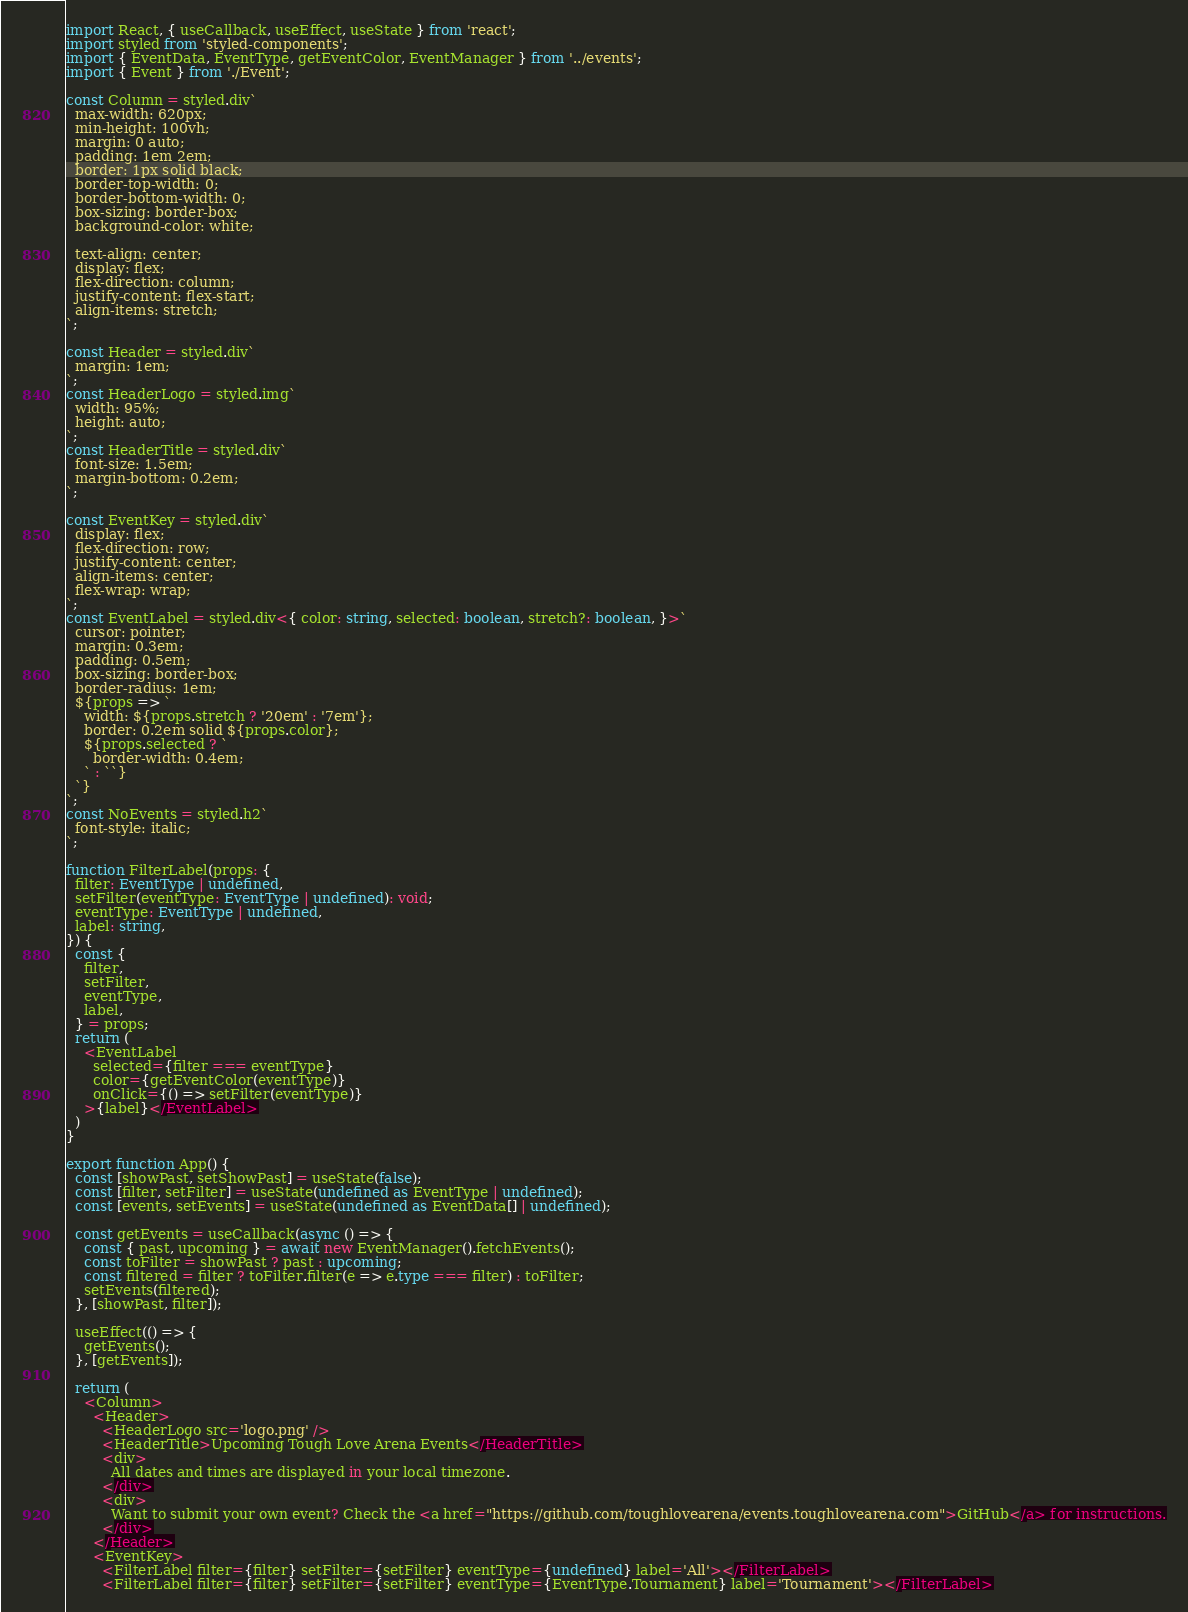Convert code to text. <code><loc_0><loc_0><loc_500><loc_500><_TypeScript_>import React, { useCallback, useEffect, useState } from 'react';
import styled from 'styled-components';
import { EventData, EventType, getEventColor, EventManager } from '../events';
import { Event } from './Event';

const Column = styled.div`
  max-width: 620px;
  min-height: 100vh;
  margin: 0 auto;
  padding: 1em 2em;
  border: 1px solid black;
  border-top-width: 0;
  border-bottom-width: 0;
  box-sizing: border-box;
  background-color: white;

  text-align: center;
  display: flex;
  flex-direction: column;
  justify-content: flex-start;
  align-items: stretch;
`;

const Header = styled.div`
  margin: 1em;
`;
const HeaderLogo = styled.img`
  width: 95%;
  height: auto;
`;
const HeaderTitle = styled.div`
  font-size: 1.5em;
  margin-bottom: 0.2em;
`;

const EventKey = styled.div`
  display: flex;
  flex-direction: row;
  justify-content: center;
  align-items: center;
  flex-wrap: wrap;
`;
const EventLabel = styled.div<{ color: string, selected: boolean, stretch?: boolean, }>`
  cursor: pointer;
  margin: 0.3em;
  padding: 0.5em;
  box-sizing: border-box;
  border-radius: 1em;
  ${props => `
    width: ${props.stretch ? '20em' : '7em'};
    border: 0.2em solid ${props.color};
    ${props.selected ? `
      border-width: 0.4em;
    ` : ``}
  `}
`;
const NoEvents = styled.h2`
  font-style: italic;
`;

function FilterLabel(props: {
  filter: EventType | undefined,
  setFilter(eventType: EventType | undefined): void;
  eventType: EventType | undefined,
  label: string,
}) {
  const {
    filter,
    setFilter,
    eventType,
    label,
  } = props;
  return (
    <EventLabel
      selected={filter === eventType}
      color={getEventColor(eventType)}
      onClick={() => setFilter(eventType)}
    >{label}</EventLabel>
  )
}

export function App() {
  const [showPast, setShowPast] = useState(false);
  const [filter, setFilter] = useState(undefined as EventType | undefined);
  const [events, setEvents] = useState(undefined as EventData[] | undefined);

  const getEvents = useCallback(async () => {
    const { past, upcoming } = await new EventManager().fetchEvents();
    const toFilter = showPast ? past : upcoming;
    const filtered = filter ? toFilter.filter(e => e.type === filter) : toFilter;
    setEvents(filtered);
  }, [showPast, filter]);

  useEffect(() => {
    getEvents();
  }, [getEvents]);

  return (
    <Column>
      <Header>
        <HeaderLogo src='logo.png' />
        <HeaderTitle>Upcoming Tough Love Arena Events</HeaderTitle>
        <div>
          All dates and times are displayed in your local timezone.
        </div>
        <div>
          Want to submit your own event? Check the <a href="https://github.com/toughlovearena/events.toughlovearena.com">GitHub</a> for instructions.
        </div>
      </Header>
      <EventKey>
        <FilterLabel filter={filter} setFilter={setFilter} eventType={undefined} label='All'></FilterLabel>
        <FilterLabel filter={filter} setFilter={setFilter} eventType={EventType.Tournament} label='Tournament'></FilterLabel></code> 